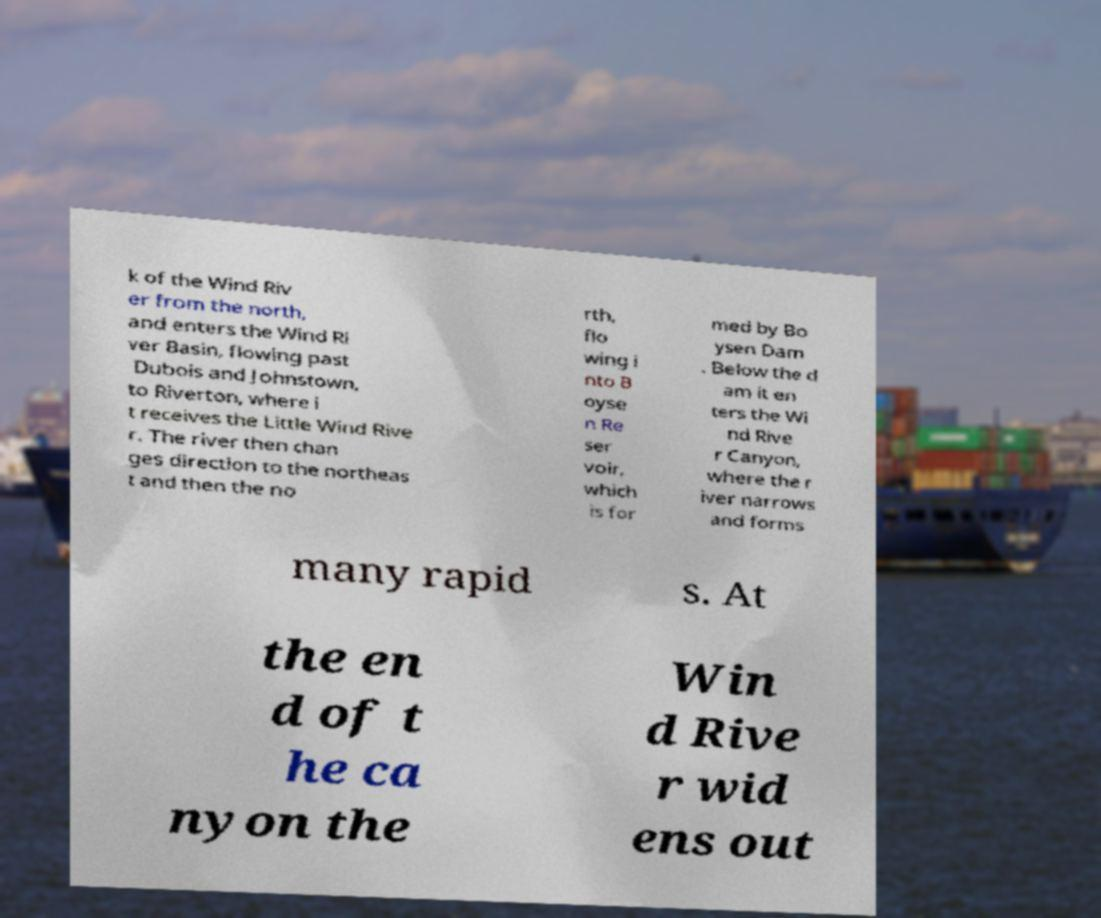Could you assist in decoding the text presented in this image and type it out clearly? k of the Wind Riv er from the north, and enters the Wind Ri ver Basin, flowing past Dubois and Johnstown, to Riverton, where i t receives the Little Wind Rive r. The river then chan ges direction to the northeas t and then the no rth, flo wing i nto B oyse n Re ser voir, which is for med by Bo ysen Dam . Below the d am it en ters the Wi nd Rive r Canyon, where the r iver narrows and forms many rapid s. At the en d of t he ca nyon the Win d Rive r wid ens out 